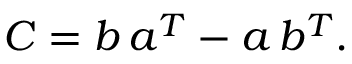Convert formula to latex. <formula><loc_0><loc_0><loc_500><loc_500>C = b \, a ^ { T } - a \, b ^ { T } .</formula> 